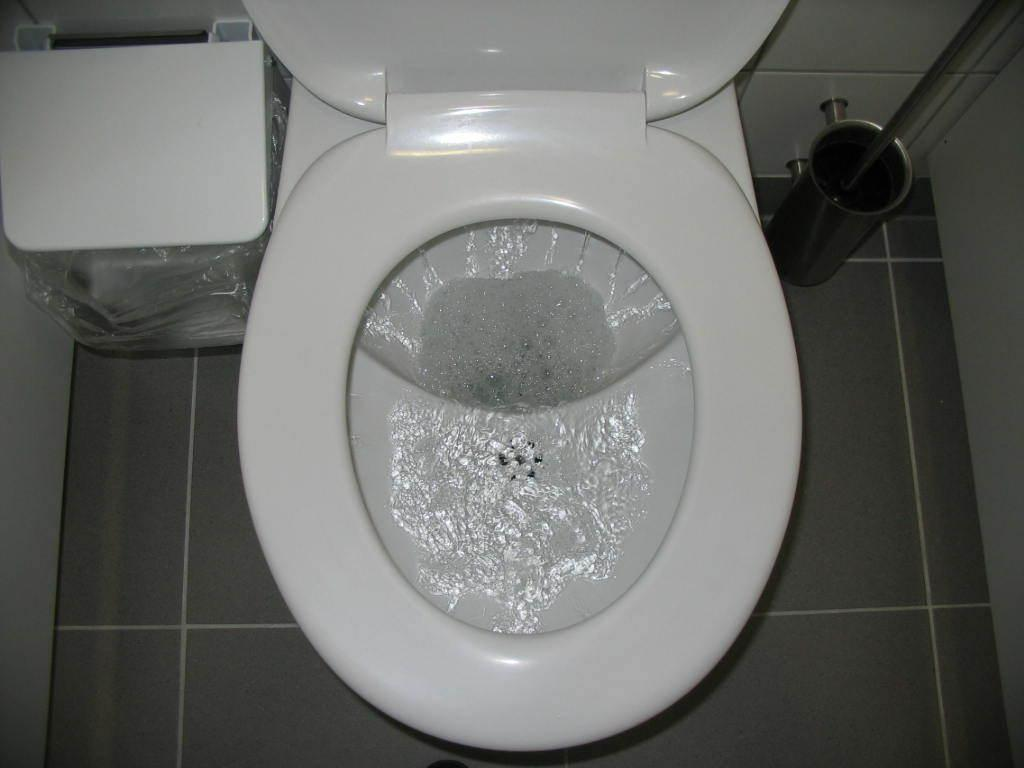What object is placed on the floor in the image? There is a toilet seat on the floor in the image. What can be seen in the background of the image? There is a wall visible in the background of the image, and there are some objects present as well. What news headline can be seen on the wall in the image? There is no news headline visible on the wall in the image. 